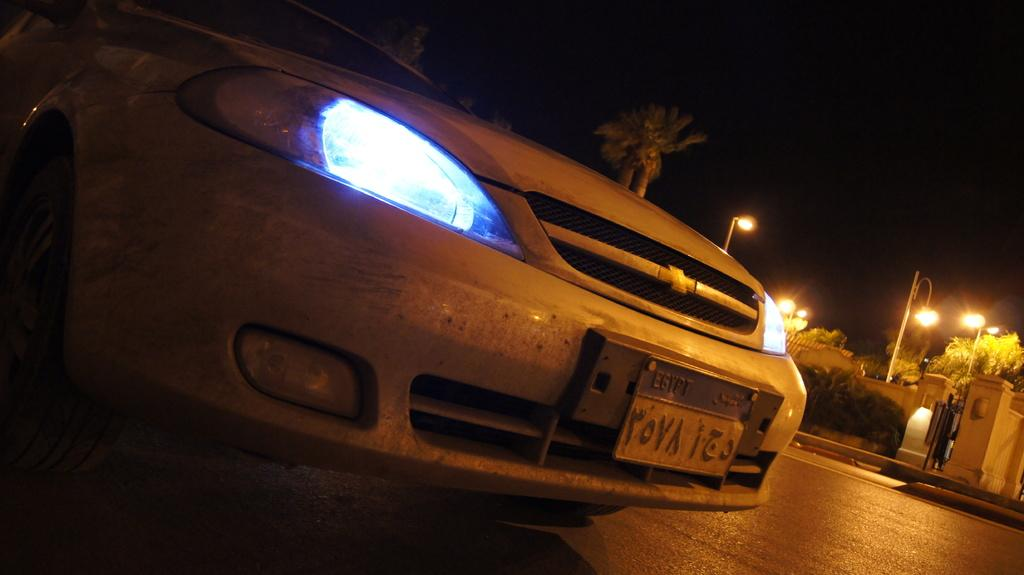What type of structure is present in the image? There is a building in the image. What can be seen illuminated in the image? There are lights visible in the image. What type of vegetation is present in the image? There are trees in the image. What type of vehicle is on the road in the image? There is a car on the road in the image. What type of haircut is the building getting in the image? The building is not getting a haircut in the image, as buildings do not have hair. 